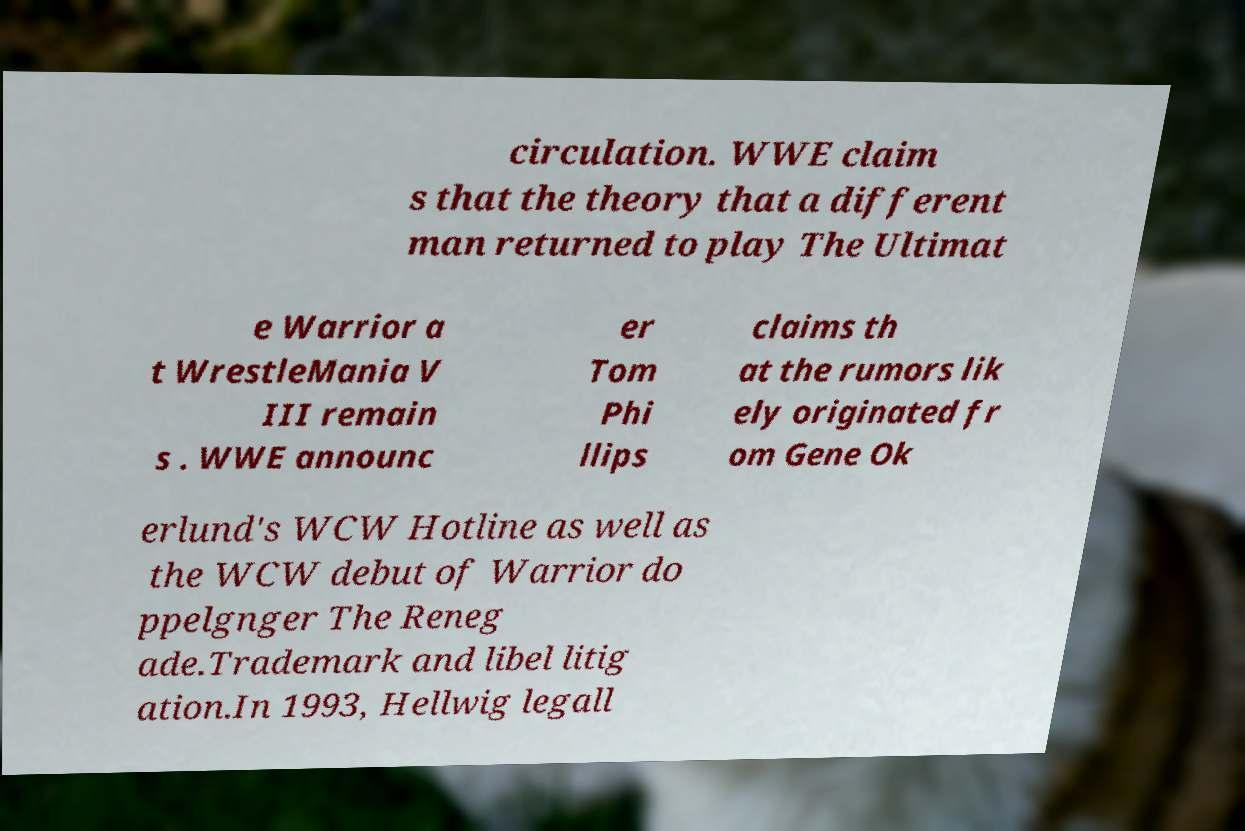Can you accurately transcribe the text from the provided image for me? circulation. WWE claim s that the theory that a different man returned to play The Ultimat e Warrior a t WrestleMania V III remain s . WWE announc er Tom Phi llips claims th at the rumors lik ely originated fr om Gene Ok erlund's WCW Hotline as well as the WCW debut of Warrior do ppelgnger The Reneg ade.Trademark and libel litig ation.In 1993, Hellwig legall 